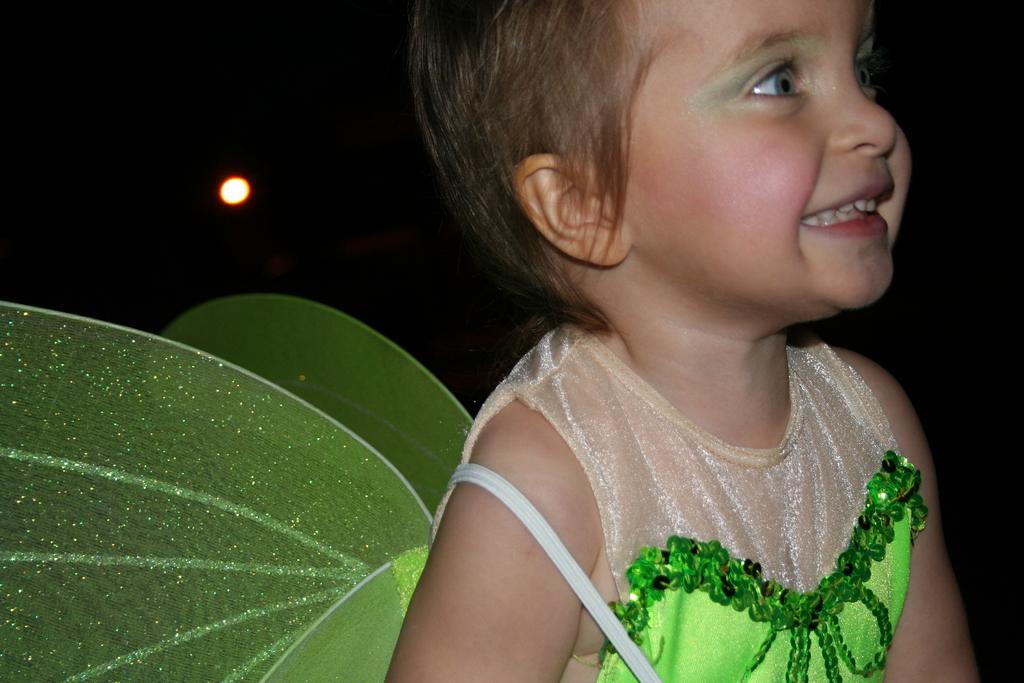What is the main subject of the image? There is a child in the image. What is the child wearing? The child is wearing a cream and green color dress. What is the child's expression in the image? The child is smiling. What can be seen in the background of the image? The background of the image is dark. Is there any source of light visible in the image? Yes, there is a light visible in the image. How many cacti are present in the image? There are no cacti present in the image; it features a child wearing a dress and smiling against a dark background. What type of muscle is being exercised by the child in the image? There is no indication of any muscle exercise in the image; the child is simply smiling and wearing a dress. 